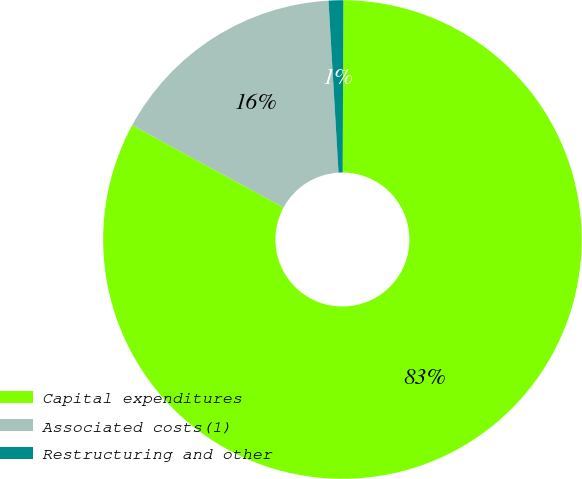Convert chart to OTSL. <chart><loc_0><loc_0><loc_500><loc_500><pie_chart><fcel>Capital expenditures<fcel>Associated costs(1)<fcel>Restructuring and other<nl><fcel>82.86%<fcel>16.15%<fcel>0.99%<nl></chart> 